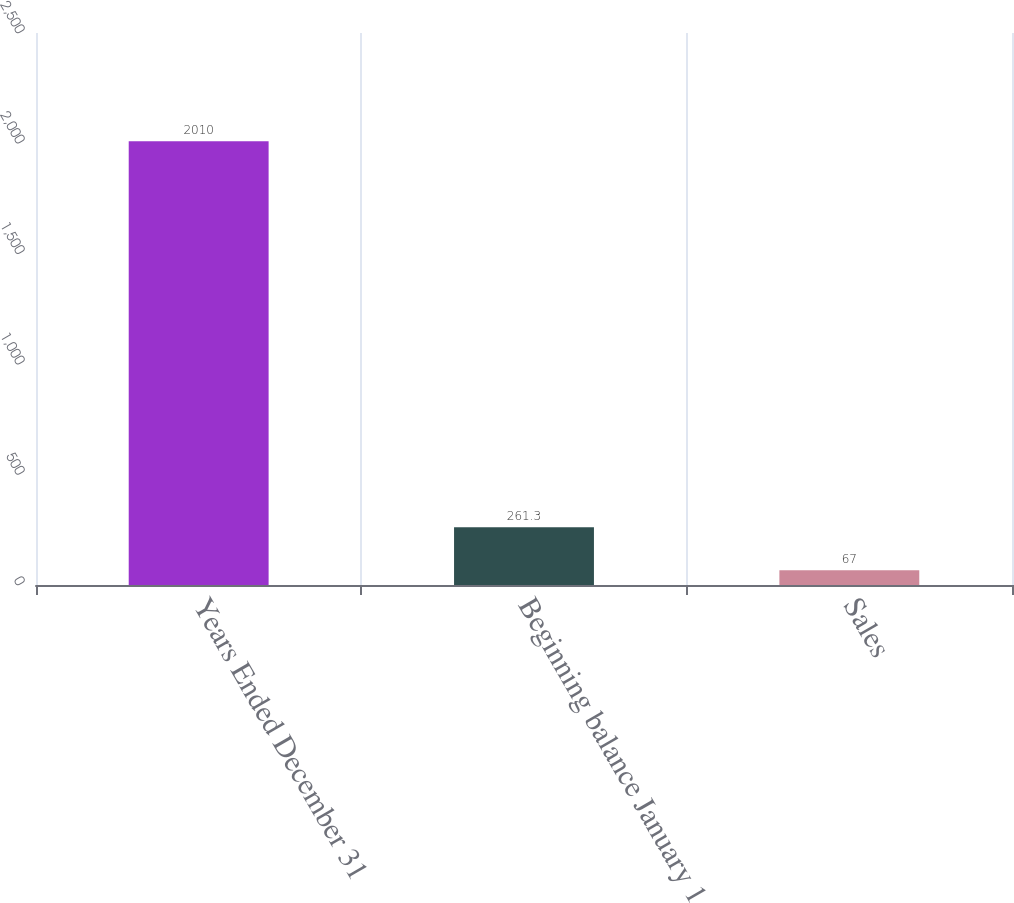<chart> <loc_0><loc_0><loc_500><loc_500><bar_chart><fcel>Years Ended December 31<fcel>Beginning balance January 1<fcel>Sales<nl><fcel>2010<fcel>261.3<fcel>67<nl></chart> 